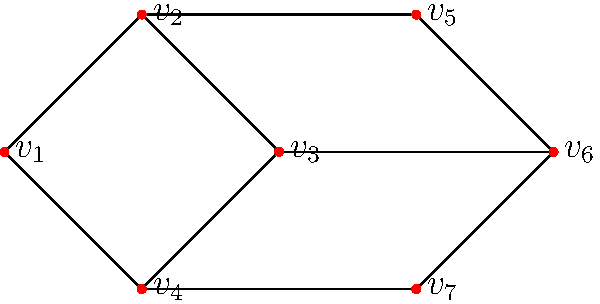Given the graph representing a scheduling problem for a machine learning project, where vertices represent tasks and edges represent conflicts (tasks that cannot be scheduled simultaneously), what is the minimum number of time slots needed to complete all tasks without conflicts? Assume each task takes one time slot. To solve this problem, we need to use graph coloring:

1. Recognize that this is a graph coloring problem where each color represents a time slot.
2. The goal is to find the chromatic number of the graph, which is the minimum number of colors needed to color all vertices such that no adjacent vertices have the same color.
3. Analyze the graph structure:
   - The graph has 7 vertices (tasks).
   - There's a clique (complete subgraph) of size 4 (v1, v2, v3, v4).
4. The chromatic number is at least as large as the size of the largest clique.
5. Start coloring from the clique:
   - Assign 4 different colors to v1, v2, v3, and v4.
6. Continue coloring the remaining vertices:
   - v5 can use the same color as v3.
   - v6 needs a new color as it's connected to v2 and v5.
   - v7 can use the same color as v2.
7. In total, we used 5 colors.
8. Verify that no adjacent vertices have the same color.

Therefore, the minimum number of time slots needed is 5.
Answer: 5 time slots 